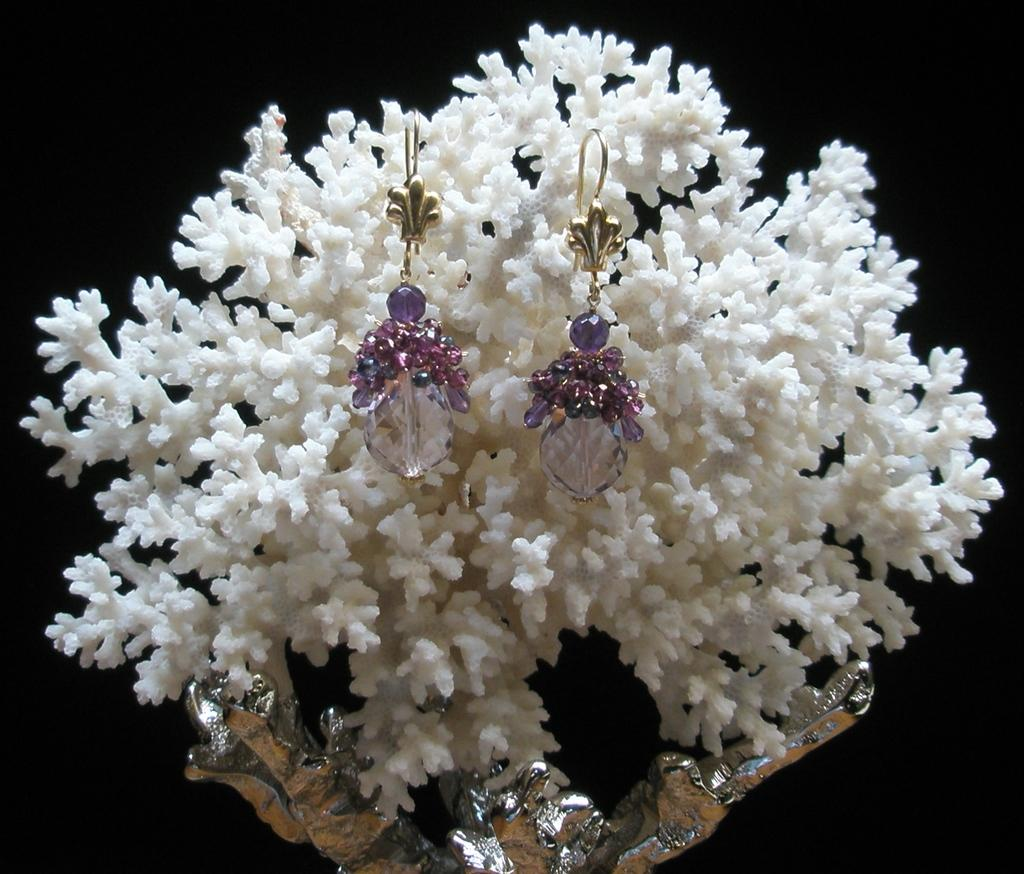What type of accessory is present in the image? There is a pair of earrings inferred from the transcript. How are the earrings displayed in the image? The pair of earrings is hung on a white-colored decorative item. What color is the background of the image? The background of the image is white. What type of wire is holding the rock in the image? There is no wire or rock present in the image; it features a pair of earrings hung on a white-colored decorative item. How many friends are visible in the image? There are no friends visible in the image; it features a pair of earrings hung on a white-colored decorative item. 